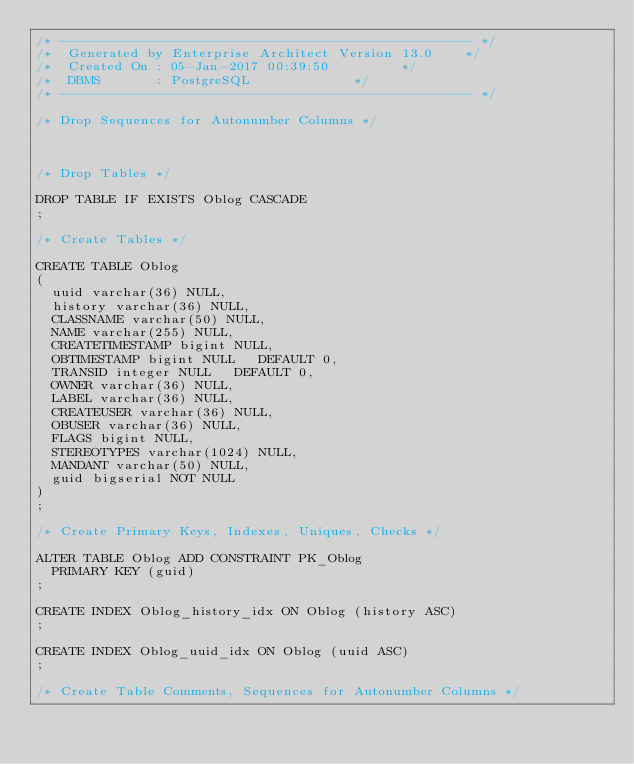<code> <loc_0><loc_0><loc_500><loc_500><_SQL_>/* ---------------------------------------------------- */
/*  Generated by Enterprise Architect Version 13.0 		*/
/*  Created On : 05-Jan-2017 00:39:50 				*/
/*  DBMS       : PostgreSQL 						*/
/* ---------------------------------------------------- */

/* Drop Sequences for Autonumber Columns */

 

/* Drop Tables */

DROP TABLE IF EXISTS Oblog CASCADE
;

/* Create Tables */

CREATE TABLE Oblog
(
	uuid varchar(36) NULL,
	history varchar(36) NULL,
	CLASSNAME varchar(50) NULL,
	NAME varchar(255) NULL,
	CREATETIMESTAMP bigint NULL,
	OBTIMESTAMP bigint NULL   DEFAULT 0,
	TRANSID integer NULL   DEFAULT 0,
	OWNER varchar(36) NULL,
	LABEL varchar(36) NULL,
	CREATEUSER varchar(36) NULL,
	OBUSER varchar(36) NULL,
	FLAGS bigint NULL,
	STEREOTYPES varchar(1024) NULL,
	MANDANT varchar(50) NULL,
	guid bigserial NOT NULL
)
;

/* Create Primary Keys, Indexes, Uniques, Checks */

ALTER TABLE Oblog ADD CONSTRAINT PK_Oblog
	PRIMARY KEY (guid)
;

CREATE INDEX Oblog_history_idx ON Oblog (history ASC)
;

CREATE INDEX Oblog_uuid_idx ON Oblog (uuid ASC)
;

/* Create Table Comments, Sequences for Autonumber Columns */

 </code> 